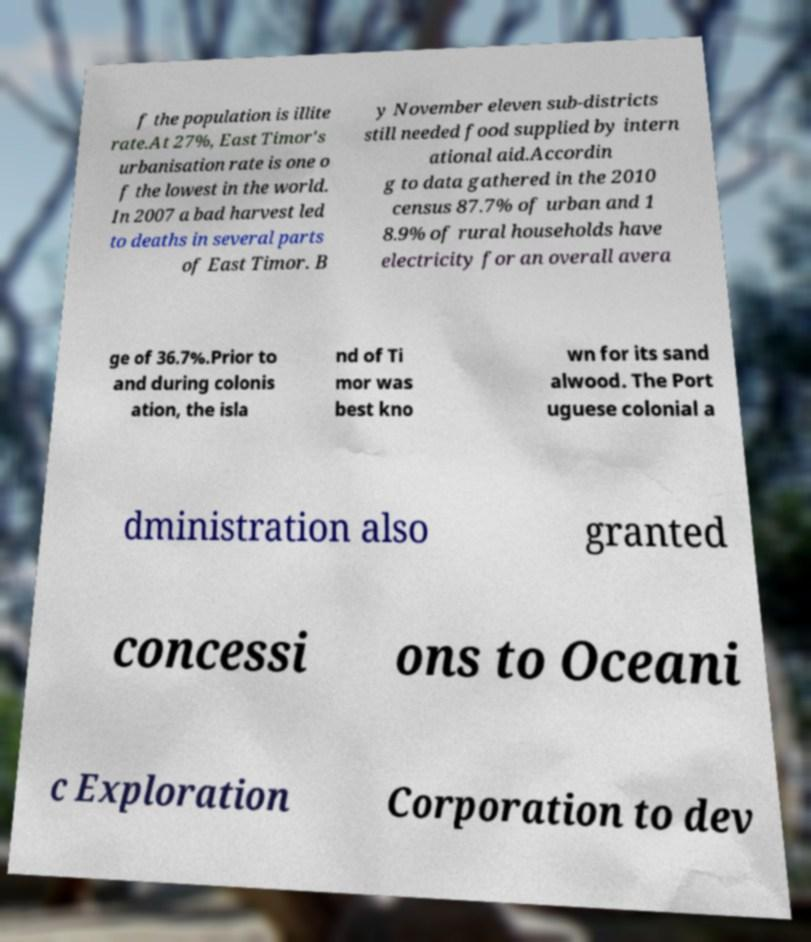Can you read and provide the text displayed in the image?This photo seems to have some interesting text. Can you extract and type it out for me? f the population is illite rate.At 27%, East Timor's urbanisation rate is one o f the lowest in the world. In 2007 a bad harvest led to deaths in several parts of East Timor. B y November eleven sub-districts still needed food supplied by intern ational aid.Accordin g to data gathered in the 2010 census 87.7% of urban and 1 8.9% of rural households have electricity for an overall avera ge of 36.7%.Prior to and during colonis ation, the isla nd of Ti mor was best kno wn for its sand alwood. The Port uguese colonial a dministration also granted concessi ons to Oceani c Exploration Corporation to dev 